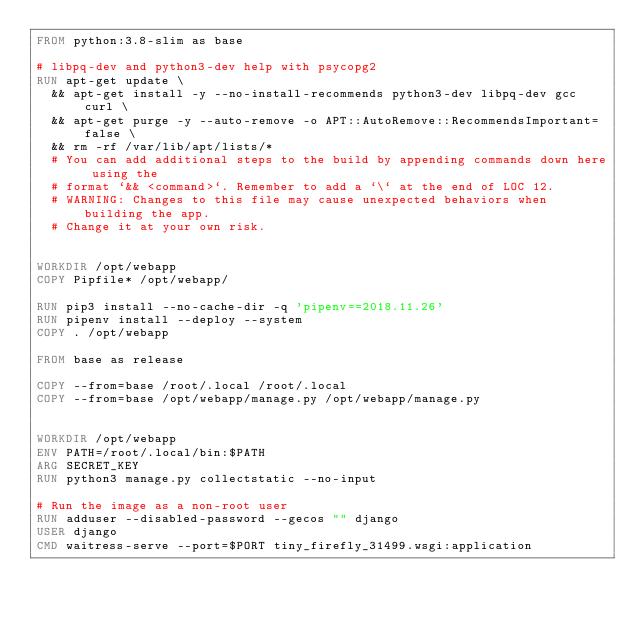<code> <loc_0><loc_0><loc_500><loc_500><_Dockerfile_>FROM python:3.8-slim as base

# libpq-dev and python3-dev help with psycopg2
RUN apt-get update \
  && apt-get install -y --no-install-recommends python3-dev libpq-dev gcc curl \
  && apt-get purge -y --auto-remove -o APT::AutoRemove::RecommendsImportant=false \
  && rm -rf /var/lib/apt/lists/*
  # You can add additional steps to the build by appending commands down here using the
  # format `&& <command>`. Remember to add a `\` at the end of LOC 12.
  # WARNING: Changes to this file may cause unexpected behaviors when building the app.
  # Change it at your own risk.


WORKDIR /opt/webapp
COPY Pipfile* /opt/webapp/

RUN pip3 install --no-cache-dir -q 'pipenv==2018.11.26' 
RUN pipenv install --deploy --system
COPY . /opt/webapp

FROM base as release

COPY --from=base /root/.local /root/.local
COPY --from=base /opt/webapp/manage.py /opt/webapp/manage.py


WORKDIR /opt/webapp
ENV PATH=/root/.local/bin:$PATH
ARG SECRET_KEY 
RUN python3 manage.py collectstatic --no-input

# Run the image as a non-root user
RUN adduser --disabled-password --gecos "" django
USER django
CMD waitress-serve --port=$PORT tiny_firefly_31499.wsgi:application
</code> 